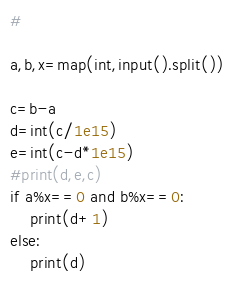<code> <loc_0><loc_0><loc_500><loc_500><_Python_># 

a,b,x=map(int,input().split())

c=b-a
d=int(c/1e15)
e=int(c-d*1e15)
#print(d,e,c)
if a%x==0 and b%x==0:
    print(d+1)
else:
    print(d)
</code> 